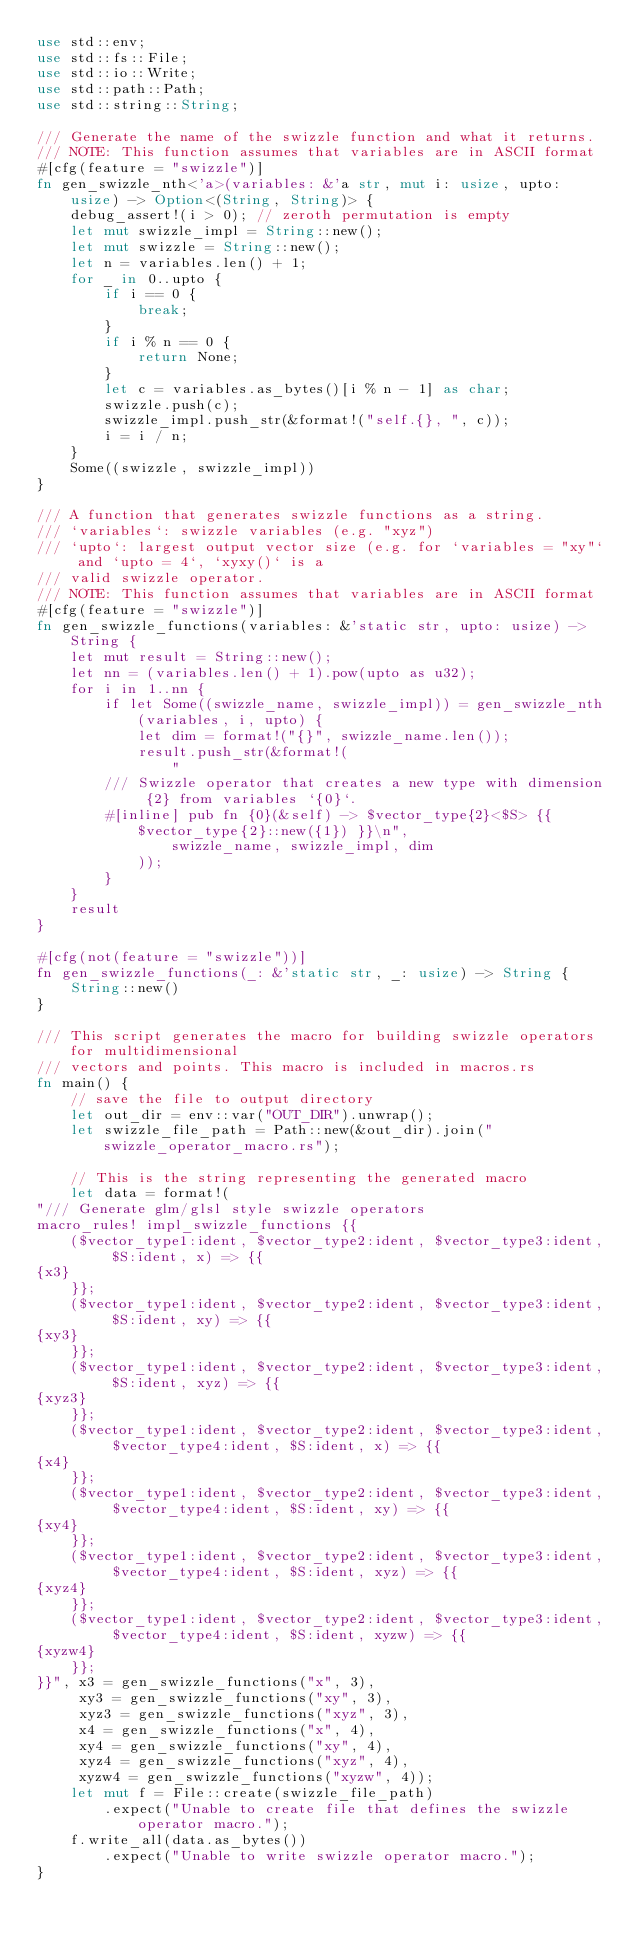<code> <loc_0><loc_0><loc_500><loc_500><_Rust_>use std::env;
use std::fs::File;
use std::io::Write;
use std::path::Path;
use std::string::String;

/// Generate the name of the swizzle function and what it returns.
/// NOTE: This function assumes that variables are in ASCII format
#[cfg(feature = "swizzle")]
fn gen_swizzle_nth<'a>(variables: &'a str, mut i: usize, upto: usize) -> Option<(String, String)> {
    debug_assert!(i > 0); // zeroth permutation is empty
    let mut swizzle_impl = String::new();
    let mut swizzle = String::new();
    let n = variables.len() + 1;
    for _ in 0..upto {
        if i == 0 {
            break;
        }
        if i % n == 0 {
            return None;
        }
        let c = variables.as_bytes()[i % n - 1] as char;
        swizzle.push(c);
        swizzle_impl.push_str(&format!("self.{}, ", c));
        i = i / n;
    }
    Some((swizzle, swizzle_impl))
}

/// A function that generates swizzle functions as a string.
/// `variables`: swizzle variables (e.g. "xyz")
/// `upto`: largest output vector size (e.g. for `variables = "xy"` and `upto = 4`, `xyxy()` is a
/// valid swizzle operator.
/// NOTE: This function assumes that variables are in ASCII format
#[cfg(feature = "swizzle")]
fn gen_swizzle_functions(variables: &'static str, upto: usize) -> String {
    let mut result = String::new();
    let nn = (variables.len() + 1).pow(upto as u32);
    for i in 1..nn {
        if let Some((swizzle_name, swizzle_impl)) = gen_swizzle_nth(variables, i, upto) {
            let dim = format!("{}", swizzle_name.len());
            result.push_str(&format!(
                "
        /// Swizzle operator that creates a new type with dimension {2} from variables `{0}`.
        #[inline] pub fn {0}(&self) -> $vector_type{2}<$S> {{ $vector_type{2}::new({1}) }}\n",
                swizzle_name, swizzle_impl, dim
            ));
        }
    }
    result
}

#[cfg(not(feature = "swizzle"))]
fn gen_swizzle_functions(_: &'static str, _: usize) -> String {
    String::new()
}

/// This script generates the macro for building swizzle operators for multidimensional
/// vectors and points. This macro is included in macros.rs
fn main() {
    // save the file to output directory
    let out_dir = env::var("OUT_DIR").unwrap();
    let swizzle_file_path = Path::new(&out_dir).join("swizzle_operator_macro.rs");

    // This is the string representing the generated macro
    let data = format!(
"/// Generate glm/glsl style swizzle operators
macro_rules! impl_swizzle_functions {{
    ($vector_type1:ident, $vector_type2:ident, $vector_type3:ident, $S:ident, x) => {{
{x3}
    }};
    ($vector_type1:ident, $vector_type2:ident, $vector_type3:ident, $S:ident, xy) => {{
{xy3}
    }};
    ($vector_type1:ident, $vector_type2:ident, $vector_type3:ident, $S:ident, xyz) => {{
{xyz3}
    }};
    ($vector_type1:ident, $vector_type2:ident, $vector_type3:ident, $vector_type4:ident, $S:ident, x) => {{
{x4}
    }};
    ($vector_type1:ident, $vector_type2:ident, $vector_type3:ident, $vector_type4:ident, $S:ident, xy) => {{
{xy4}
    }};
    ($vector_type1:ident, $vector_type2:ident, $vector_type3:ident, $vector_type4:ident, $S:ident, xyz) => {{
{xyz4}
    }};
    ($vector_type1:ident, $vector_type2:ident, $vector_type3:ident, $vector_type4:ident, $S:ident, xyzw) => {{
{xyzw4}
    }};
}}", x3 = gen_swizzle_functions("x", 3),
     xy3 = gen_swizzle_functions("xy", 3),
     xyz3 = gen_swizzle_functions("xyz", 3),
     x4 = gen_swizzle_functions("x", 4),
     xy4 = gen_swizzle_functions("xy", 4),
     xyz4 = gen_swizzle_functions("xyz", 4),
     xyzw4 = gen_swizzle_functions("xyzw", 4));
    let mut f = File::create(swizzle_file_path)
        .expect("Unable to create file that defines the swizzle operator macro.");
    f.write_all(data.as_bytes())
        .expect("Unable to write swizzle operator macro.");
}
</code> 